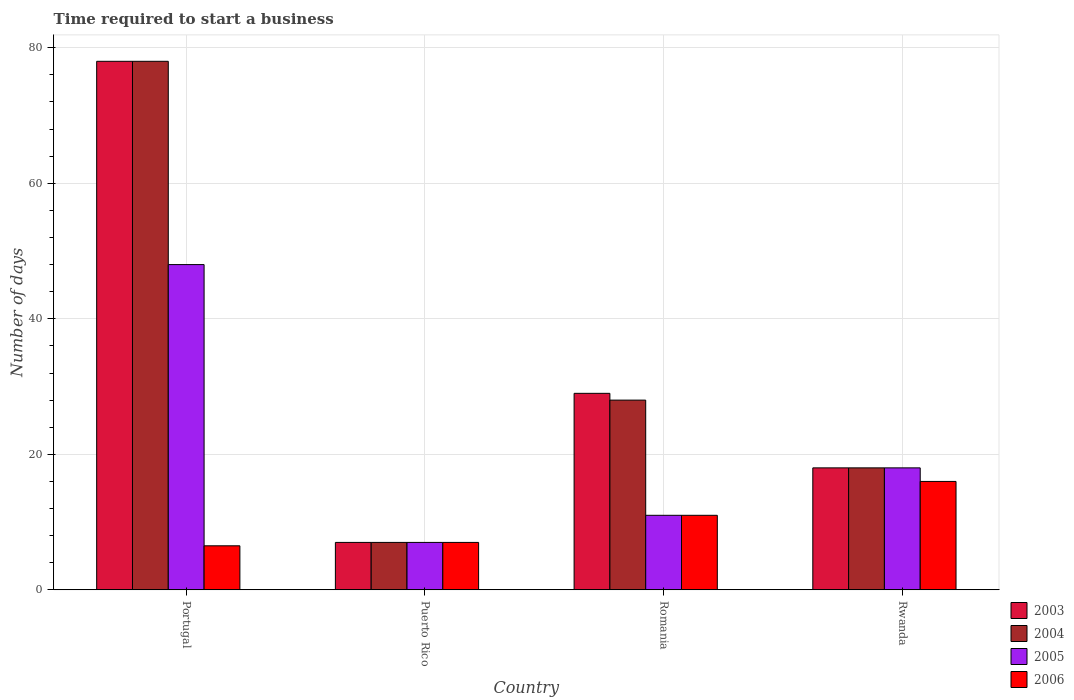How many groups of bars are there?
Ensure brevity in your answer.  4. How many bars are there on the 2nd tick from the left?
Make the answer very short. 4. How many bars are there on the 4th tick from the right?
Keep it short and to the point. 4. What is the label of the 4th group of bars from the left?
Offer a very short reply. Rwanda. Across all countries, what is the minimum number of days required to start a business in 2005?
Provide a short and direct response. 7. In which country was the number of days required to start a business in 2006 maximum?
Offer a terse response. Rwanda. In which country was the number of days required to start a business in 2003 minimum?
Provide a short and direct response. Puerto Rico. What is the difference between the number of days required to start a business in 2003 in Puerto Rico and the number of days required to start a business in 2006 in Portugal?
Provide a succinct answer. 0.5. What is the average number of days required to start a business in 2004 per country?
Provide a succinct answer. 32.75. What is the difference between the number of days required to start a business of/in 2005 and number of days required to start a business of/in 2003 in Puerto Rico?
Offer a terse response. 0. In how many countries, is the number of days required to start a business in 2004 greater than 48 days?
Provide a succinct answer. 1. What is the ratio of the number of days required to start a business in 2005 in Portugal to that in Puerto Rico?
Provide a succinct answer. 6.86. Is the difference between the number of days required to start a business in 2005 in Portugal and Puerto Rico greater than the difference between the number of days required to start a business in 2003 in Portugal and Puerto Rico?
Offer a terse response. No. In how many countries, is the number of days required to start a business in 2006 greater than the average number of days required to start a business in 2006 taken over all countries?
Offer a terse response. 2. Is the sum of the number of days required to start a business in 2005 in Romania and Rwanda greater than the maximum number of days required to start a business in 2004 across all countries?
Offer a terse response. No. Is it the case that in every country, the sum of the number of days required to start a business in 2005 and number of days required to start a business in 2003 is greater than the sum of number of days required to start a business in 2006 and number of days required to start a business in 2004?
Offer a very short reply. No. Is it the case that in every country, the sum of the number of days required to start a business in 2004 and number of days required to start a business in 2006 is greater than the number of days required to start a business in 2005?
Ensure brevity in your answer.  Yes. Does the graph contain grids?
Your answer should be compact. Yes. Where does the legend appear in the graph?
Your response must be concise. Bottom right. How many legend labels are there?
Your response must be concise. 4. How are the legend labels stacked?
Keep it short and to the point. Vertical. What is the title of the graph?
Ensure brevity in your answer.  Time required to start a business. Does "1973" appear as one of the legend labels in the graph?
Provide a short and direct response. No. What is the label or title of the Y-axis?
Ensure brevity in your answer.  Number of days. What is the Number of days in 2003 in Portugal?
Give a very brief answer. 78. What is the Number of days of 2004 in Portugal?
Make the answer very short. 78. What is the Number of days in 2004 in Puerto Rico?
Ensure brevity in your answer.  7. What is the Number of days in 2004 in Romania?
Your answer should be very brief. 28. What is the Number of days of 2006 in Romania?
Make the answer very short. 11. What is the Number of days of 2004 in Rwanda?
Provide a succinct answer. 18. What is the Number of days in 2006 in Rwanda?
Offer a terse response. 16. Across all countries, what is the maximum Number of days of 2004?
Your response must be concise. 78. Across all countries, what is the minimum Number of days of 2003?
Offer a terse response. 7. What is the total Number of days of 2003 in the graph?
Provide a short and direct response. 132. What is the total Number of days of 2004 in the graph?
Give a very brief answer. 131. What is the total Number of days in 2006 in the graph?
Keep it short and to the point. 40.5. What is the difference between the Number of days in 2003 in Portugal and that in Puerto Rico?
Provide a succinct answer. 71. What is the difference between the Number of days of 2005 in Portugal and that in Romania?
Ensure brevity in your answer.  37. What is the difference between the Number of days in 2006 in Portugal and that in Romania?
Offer a terse response. -4.5. What is the difference between the Number of days of 2003 in Portugal and that in Rwanda?
Provide a short and direct response. 60. What is the difference between the Number of days of 2005 in Portugal and that in Rwanda?
Offer a terse response. 30. What is the difference between the Number of days in 2004 in Puerto Rico and that in Romania?
Your response must be concise. -21. What is the difference between the Number of days in 2005 in Puerto Rico and that in Romania?
Provide a short and direct response. -4. What is the difference between the Number of days in 2003 in Puerto Rico and that in Rwanda?
Offer a very short reply. -11. What is the difference between the Number of days in 2005 in Puerto Rico and that in Rwanda?
Provide a succinct answer. -11. What is the difference between the Number of days of 2006 in Puerto Rico and that in Rwanda?
Offer a very short reply. -9. What is the difference between the Number of days of 2004 in Romania and that in Rwanda?
Provide a succinct answer. 10. What is the difference between the Number of days in 2005 in Romania and that in Rwanda?
Keep it short and to the point. -7. What is the difference between the Number of days of 2003 in Portugal and the Number of days of 2005 in Puerto Rico?
Your answer should be compact. 71. What is the difference between the Number of days of 2003 in Portugal and the Number of days of 2006 in Puerto Rico?
Offer a terse response. 71. What is the difference between the Number of days of 2003 in Portugal and the Number of days of 2004 in Romania?
Provide a short and direct response. 50. What is the difference between the Number of days in 2004 in Portugal and the Number of days in 2006 in Romania?
Provide a succinct answer. 67. What is the difference between the Number of days of 2004 in Portugal and the Number of days of 2005 in Rwanda?
Your answer should be very brief. 60. What is the difference between the Number of days of 2004 in Portugal and the Number of days of 2006 in Rwanda?
Give a very brief answer. 62. What is the difference between the Number of days in 2005 in Portugal and the Number of days in 2006 in Rwanda?
Ensure brevity in your answer.  32. What is the difference between the Number of days in 2003 in Puerto Rico and the Number of days in 2005 in Romania?
Provide a short and direct response. -4. What is the difference between the Number of days of 2003 in Puerto Rico and the Number of days of 2006 in Romania?
Your response must be concise. -4. What is the difference between the Number of days of 2004 in Puerto Rico and the Number of days of 2006 in Romania?
Provide a succinct answer. -4. What is the difference between the Number of days of 2003 in Puerto Rico and the Number of days of 2004 in Rwanda?
Ensure brevity in your answer.  -11. What is the difference between the Number of days of 2003 in Puerto Rico and the Number of days of 2005 in Rwanda?
Provide a succinct answer. -11. What is the difference between the Number of days in 2003 in Puerto Rico and the Number of days in 2006 in Rwanda?
Offer a very short reply. -9. What is the difference between the Number of days of 2004 in Puerto Rico and the Number of days of 2005 in Rwanda?
Your answer should be very brief. -11. What is the difference between the Number of days in 2004 in Puerto Rico and the Number of days in 2006 in Rwanda?
Ensure brevity in your answer.  -9. What is the difference between the Number of days in 2003 in Romania and the Number of days in 2004 in Rwanda?
Give a very brief answer. 11. What is the difference between the Number of days of 2003 in Romania and the Number of days of 2005 in Rwanda?
Your answer should be compact. 11. What is the difference between the Number of days in 2003 in Romania and the Number of days in 2006 in Rwanda?
Give a very brief answer. 13. What is the difference between the Number of days in 2004 in Romania and the Number of days in 2006 in Rwanda?
Give a very brief answer. 12. What is the average Number of days in 2003 per country?
Your response must be concise. 33. What is the average Number of days of 2004 per country?
Your answer should be very brief. 32.75. What is the average Number of days in 2005 per country?
Keep it short and to the point. 21. What is the average Number of days in 2006 per country?
Make the answer very short. 10.12. What is the difference between the Number of days in 2003 and Number of days in 2005 in Portugal?
Your response must be concise. 30. What is the difference between the Number of days in 2003 and Number of days in 2006 in Portugal?
Offer a terse response. 71.5. What is the difference between the Number of days of 2004 and Number of days of 2006 in Portugal?
Your answer should be very brief. 71.5. What is the difference between the Number of days of 2005 and Number of days of 2006 in Portugal?
Your response must be concise. 41.5. What is the difference between the Number of days in 2003 and Number of days in 2004 in Puerto Rico?
Provide a succinct answer. 0. What is the difference between the Number of days of 2003 and Number of days of 2006 in Puerto Rico?
Make the answer very short. 0. What is the difference between the Number of days in 2004 and Number of days in 2006 in Puerto Rico?
Your answer should be very brief. 0. What is the difference between the Number of days of 2003 and Number of days of 2005 in Rwanda?
Provide a short and direct response. 0. What is the difference between the Number of days in 2003 and Number of days in 2006 in Rwanda?
Give a very brief answer. 2. What is the difference between the Number of days in 2004 and Number of days in 2005 in Rwanda?
Ensure brevity in your answer.  0. What is the difference between the Number of days in 2005 and Number of days in 2006 in Rwanda?
Your answer should be compact. 2. What is the ratio of the Number of days of 2003 in Portugal to that in Puerto Rico?
Ensure brevity in your answer.  11.14. What is the ratio of the Number of days of 2004 in Portugal to that in Puerto Rico?
Give a very brief answer. 11.14. What is the ratio of the Number of days in 2005 in Portugal to that in Puerto Rico?
Your response must be concise. 6.86. What is the ratio of the Number of days of 2006 in Portugal to that in Puerto Rico?
Ensure brevity in your answer.  0.93. What is the ratio of the Number of days in 2003 in Portugal to that in Romania?
Your answer should be compact. 2.69. What is the ratio of the Number of days in 2004 in Portugal to that in Romania?
Offer a terse response. 2.79. What is the ratio of the Number of days in 2005 in Portugal to that in Romania?
Ensure brevity in your answer.  4.36. What is the ratio of the Number of days of 2006 in Portugal to that in Romania?
Offer a very short reply. 0.59. What is the ratio of the Number of days in 2003 in Portugal to that in Rwanda?
Your answer should be compact. 4.33. What is the ratio of the Number of days of 2004 in Portugal to that in Rwanda?
Your answer should be compact. 4.33. What is the ratio of the Number of days of 2005 in Portugal to that in Rwanda?
Offer a terse response. 2.67. What is the ratio of the Number of days in 2006 in Portugal to that in Rwanda?
Offer a terse response. 0.41. What is the ratio of the Number of days in 2003 in Puerto Rico to that in Romania?
Give a very brief answer. 0.24. What is the ratio of the Number of days in 2004 in Puerto Rico to that in Romania?
Provide a short and direct response. 0.25. What is the ratio of the Number of days in 2005 in Puerto Rico to that in Romania?
Your answer should be compact. 0.64. What is the ratio of the Number of days in 2006 in Puerto Rico to that in Romania?
Your answer should be compact. 0.64. What is the ratio of the Number of days in 2003 in Puerto Rico to that in Rwanda?
Offer a very short reply. 0.39. What is the ratio of the Number of days in 2004 in Puerto Rico to that in Rwanda?
Offer a terse response. 0.39. What is the ratio of the Number of days of 2005 in Puerto Rico to that in Rwanda?
Offer a terse response. 0.39. What is the ratio of the Number of days in 2006 in Puerto Rico to that in Rwanda?
Your answer should be very brief. 0.44. What is the ratio of the Number of days in 2003 in Romania to that in Rwanda?
Keep it short and to the point. 1.61. What is the ratio of the Number of days of 2004 in Romania to that in Rwanda?
Ensure brevity in your answer.  1.56. What is the ratio of the Number of days in 2005 in Romania to that in Rwanda?
Your answer should be very brief. 0.61. What is the ratio of the Number of days in 2006 in Romania to that in Rwanda?
Give a very brief answer. 0.69. What is the difference between the highest and the second highest Number of days in 2005?
Your answer should be very brief. 30. What is the difference between the highest and the second highest Number of days in 2006?
Ensure brevity in your answer.  5. What is the difference between the highest and the lowest Number of days in 2003?
Provide a succinct answer. 71. What is the difference between the highest and the lowest Number of days in 2004?
Ensure brevity in your answer.  71. What is the difference between the highest and the lowest Number of days of 2005?
Offer a very short reply. 41. What is the difference between the highest and the lowest Number of days in 2006?
Provide a short and direct response. 9.5. 